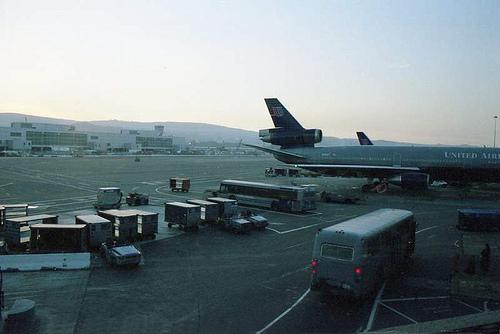What is this location called?
Quick response, please. Airport. What is on the runway?
Be succinct. Bus. Is the sky bright blue?
Short answer required. No. 